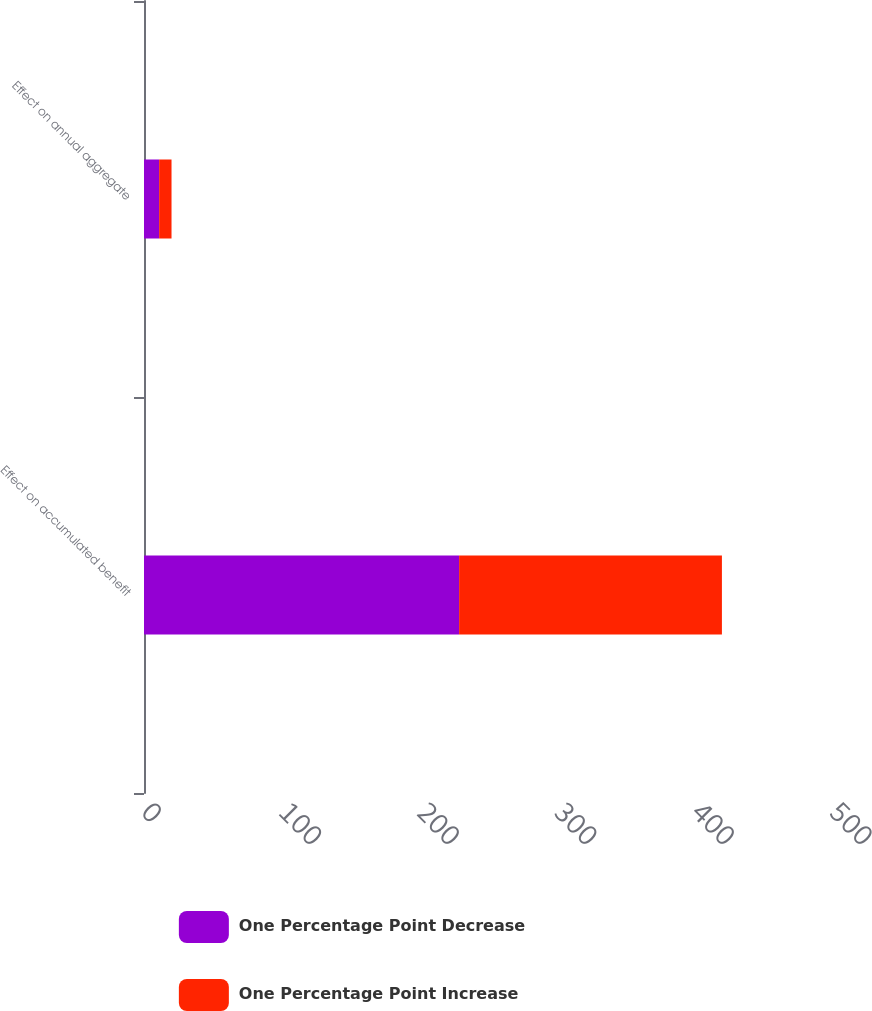<chart> <loc_0><loc_0><loc_500><loc_500><stacked_bar_chart><ecel><fcel>Effect on accumulated benefit<fcel>Effect on annual aggregate<nl><fcel>One Percentage Point Decrease<fcel>229<fcel>11<nl><fcel>One Percentage Point Increase<fcel>191<fcel>9<nl></chart> 